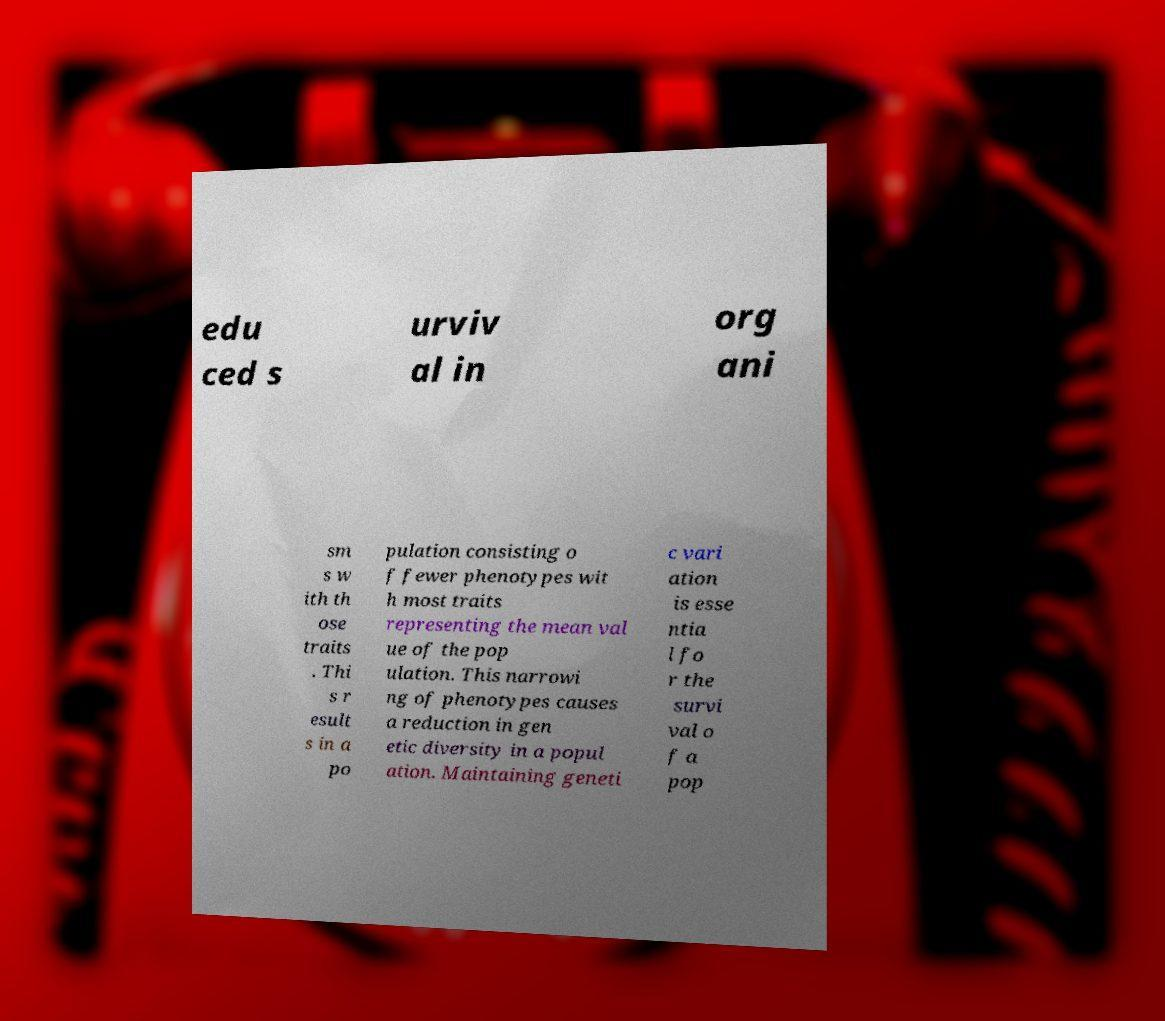Could you extract and type out the text from this image? edu ced s urviv al in org ani sm s w ith th ose traits . Thi s r esult s in a po pulation consisting o f fewer phenotypes wit h most traits representing the mean val ue of the pop ulation. This narrowi ng of phenotypes causes a reduction in gen etic diversity in a popul ation. Maintaining geneti c vari ation is esse ntia l fo r the survi val o f a pop 